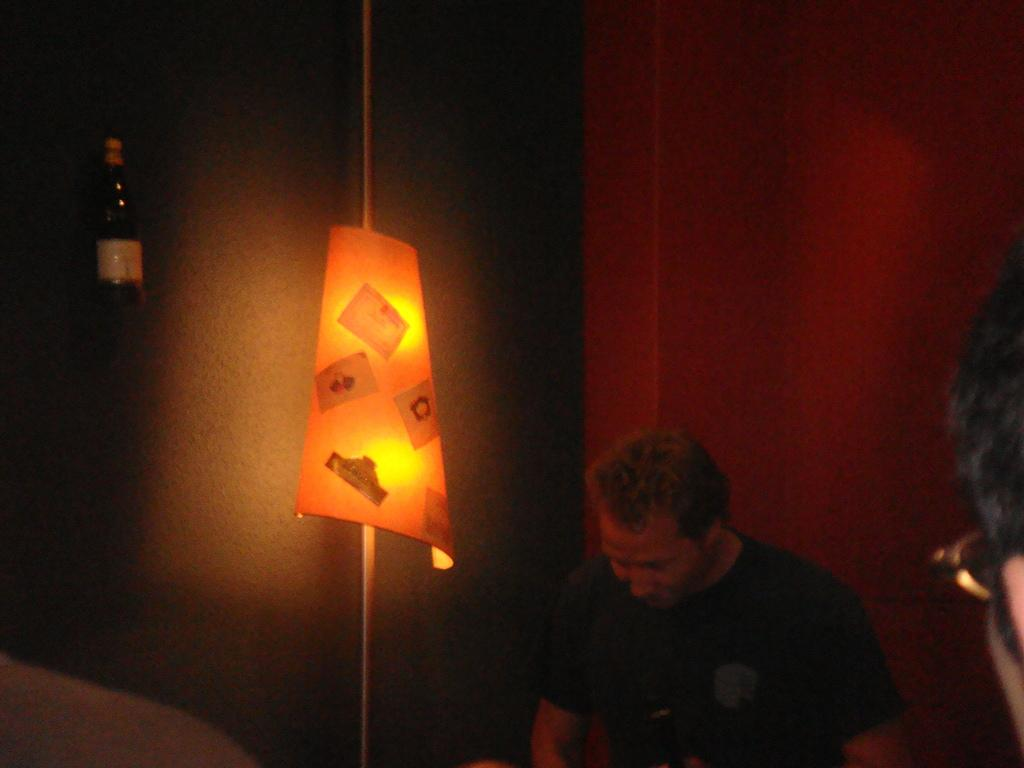Who or what can be seen in the bottom right of the image? There are two people in the bottom right of the image. What is located in the middle of the image? There is a light in the middle of the image. What object is at the top of the image? There is a bottle at the top of the image. What can be seen in the background of the image? There is a wall in the background of the image. What type of scientific experiment is being conducted in the image? There is no indication of a scientific experiment in the image; it features two people, a light, a bottle, and a wall. Can you describe the motion of the sock in the image? There is no sock present in the image, so it is not possible to describe its motion. 